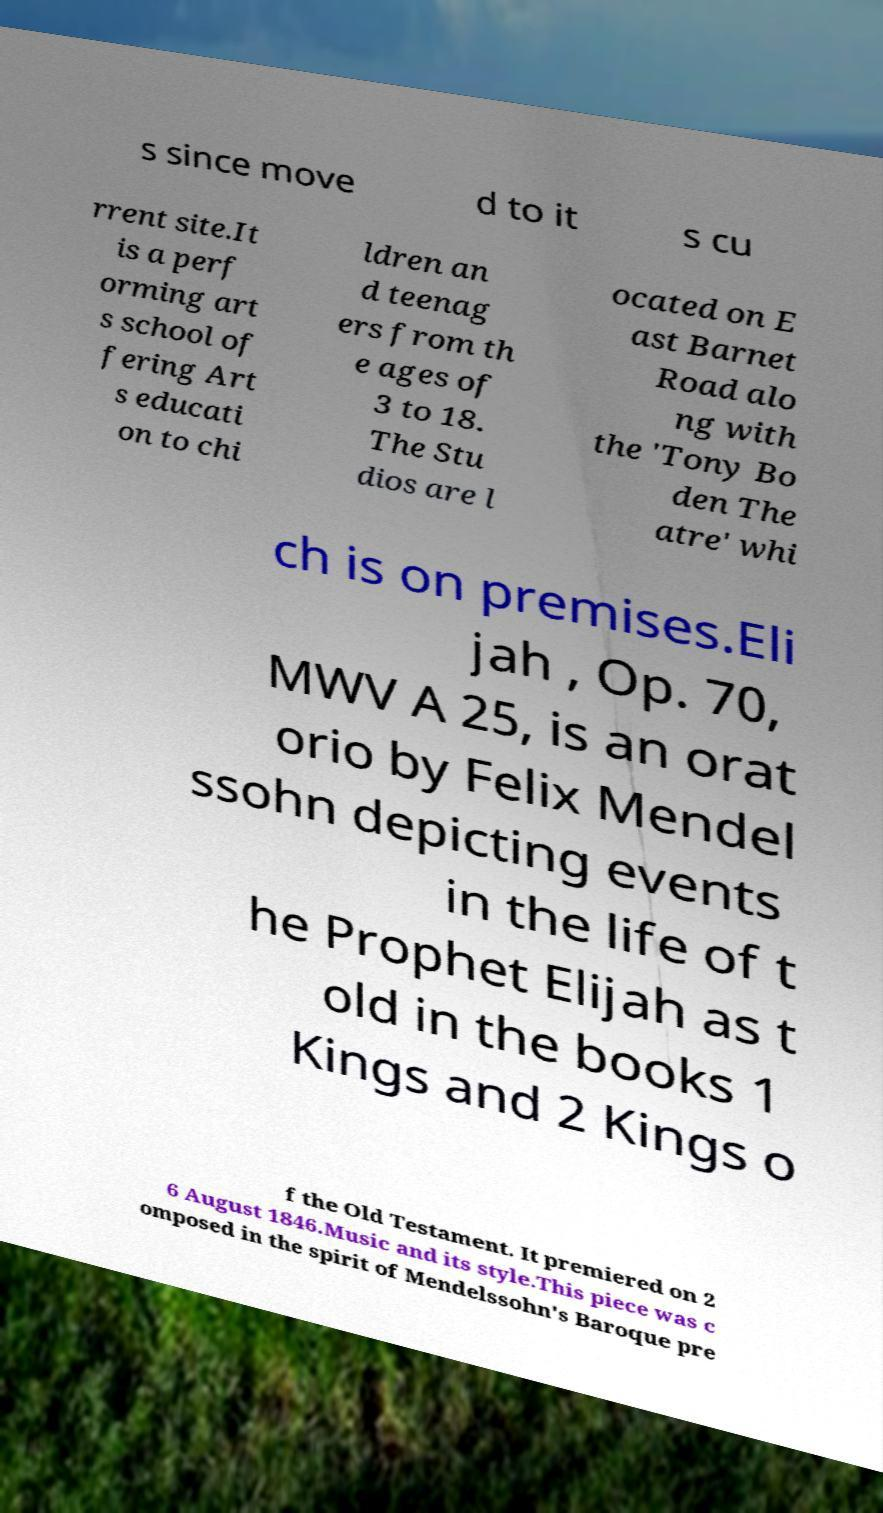I need the written content from this picture converted into text. Can you do that? s since move d to it s cu rrent site.It is a perf orming art s school of fering Art s educati on to chi ldren an d teenag ers from th e ages of 3 to 18. The Stu dios are l ocated on E ast Barnet Road alo ng with the 'Tony Bo den The atre' whi ch is on premises.Eli jah , Op. 70, MWV A 25, is an orat orio by Felix Mendel ssohn depicting events in the life of t he Prophet Elijah as t old in the books 1 Kings and 2 Kings o f the Old Testament. It premiered on 2 6 August 1846.Music and its style.This piece was c omposed in the spirit of Mendelssohn's Baroque pre 